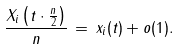<formula> <loc_0><loc_0><loc_500><loc_500>\frac { X _ { i } \left ( t \cdot \frac { n } { 2 } \right ) } { n } \, = \, x _ { i } ( t ) + o ( 1 ) .</formula> 